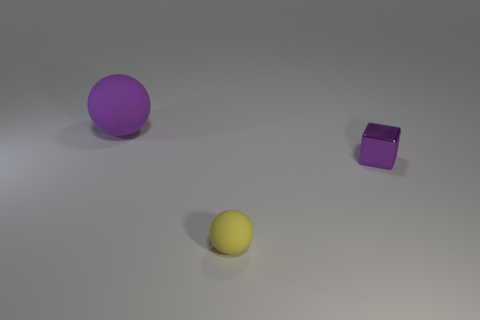Add 3 small yellow balls. How many objects exist? 6 Subtract all blocks. How many objects are left? 2 Add 2 big purple matte objects. How many big purple matte objects are left? 3 Add 2 spheres. How many spheres exist? 4 Subtract 0 red spheres. How many objects are left? 3 Subtract all metallic cubes. Subtract all tiny metal cubes. How many objects are left? 1 